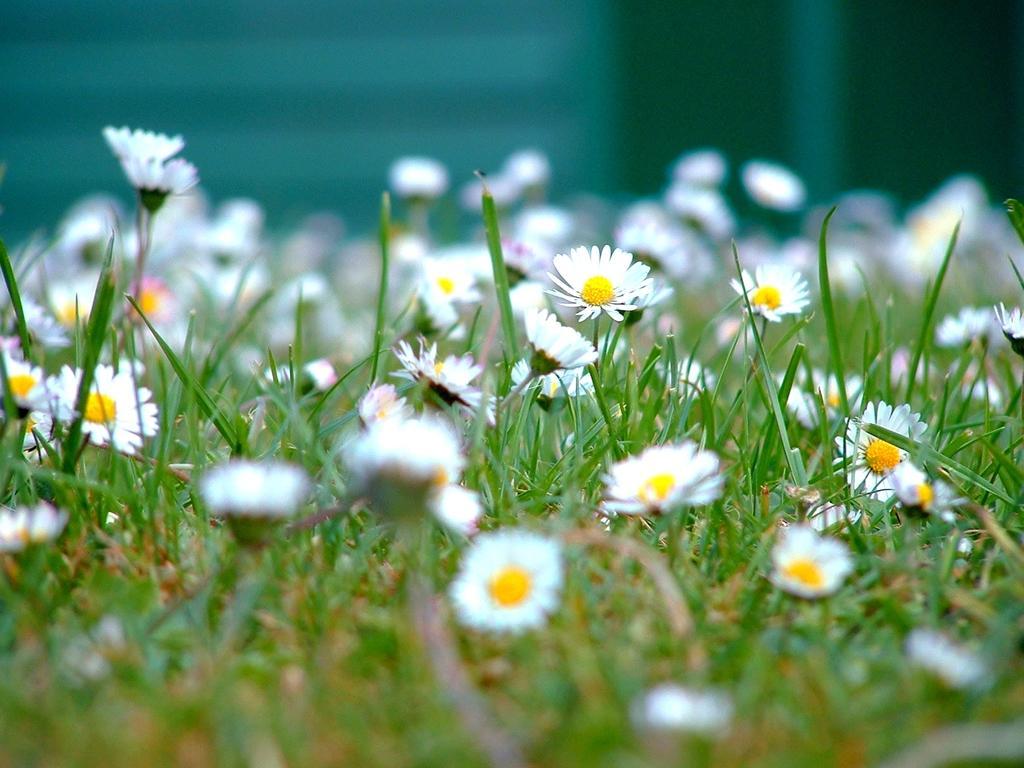Describe this image in one or two sentences. Here in this picture we can see white colored flowers present all over there on the plants present over there. 